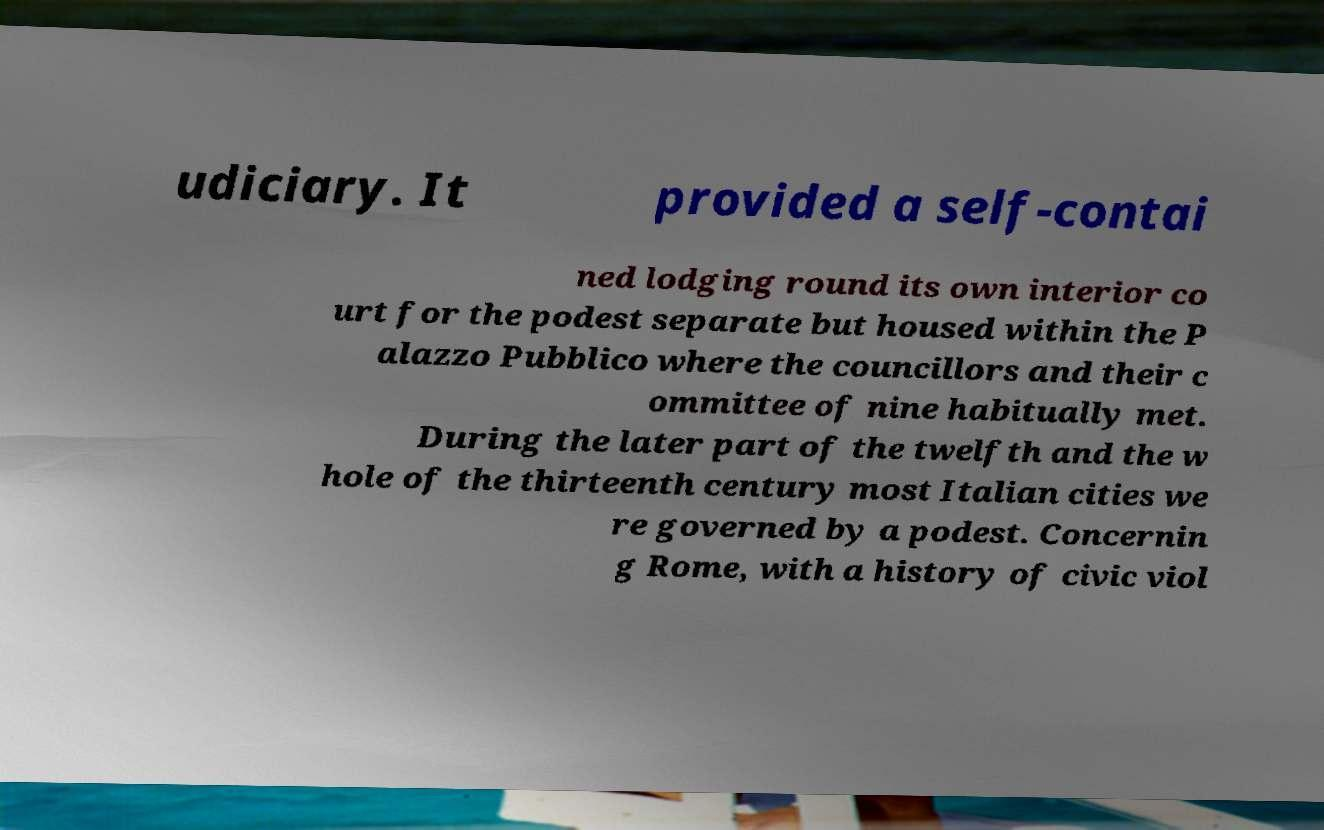For documentation purposes, I need the text within this image transcribed. Could you provide that? udiciary. It provided a self-contai ned lodging round its own interior co urt for the podest separate but housed within the P alazzo Pubblico where the councillors and their c ommittee of nine habitually met. During the later part of the twelfth and the w hole of the thirteenth century most Italian cities we re governed by a podest. Concernin g Rome, with a history of civic viol 